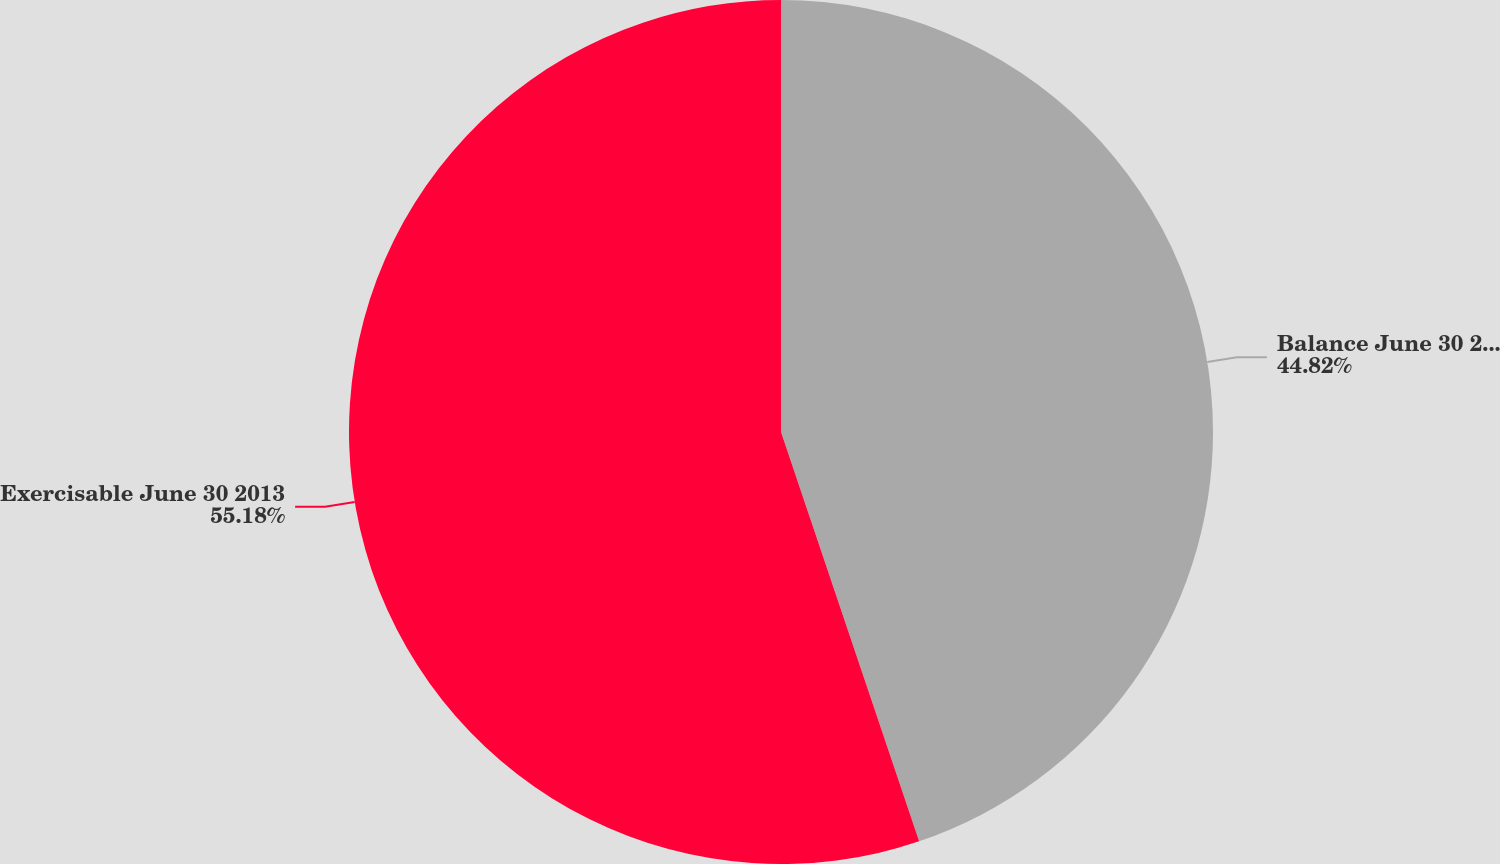<chart> <loc_0><loc_0><loc_500><loc_500><pie_chart><fcel>Balance June 30 2013<fcel>Exercisable June 30 2013<nl><fcel>44.82%<fcel>55.18%<nl></chart> 